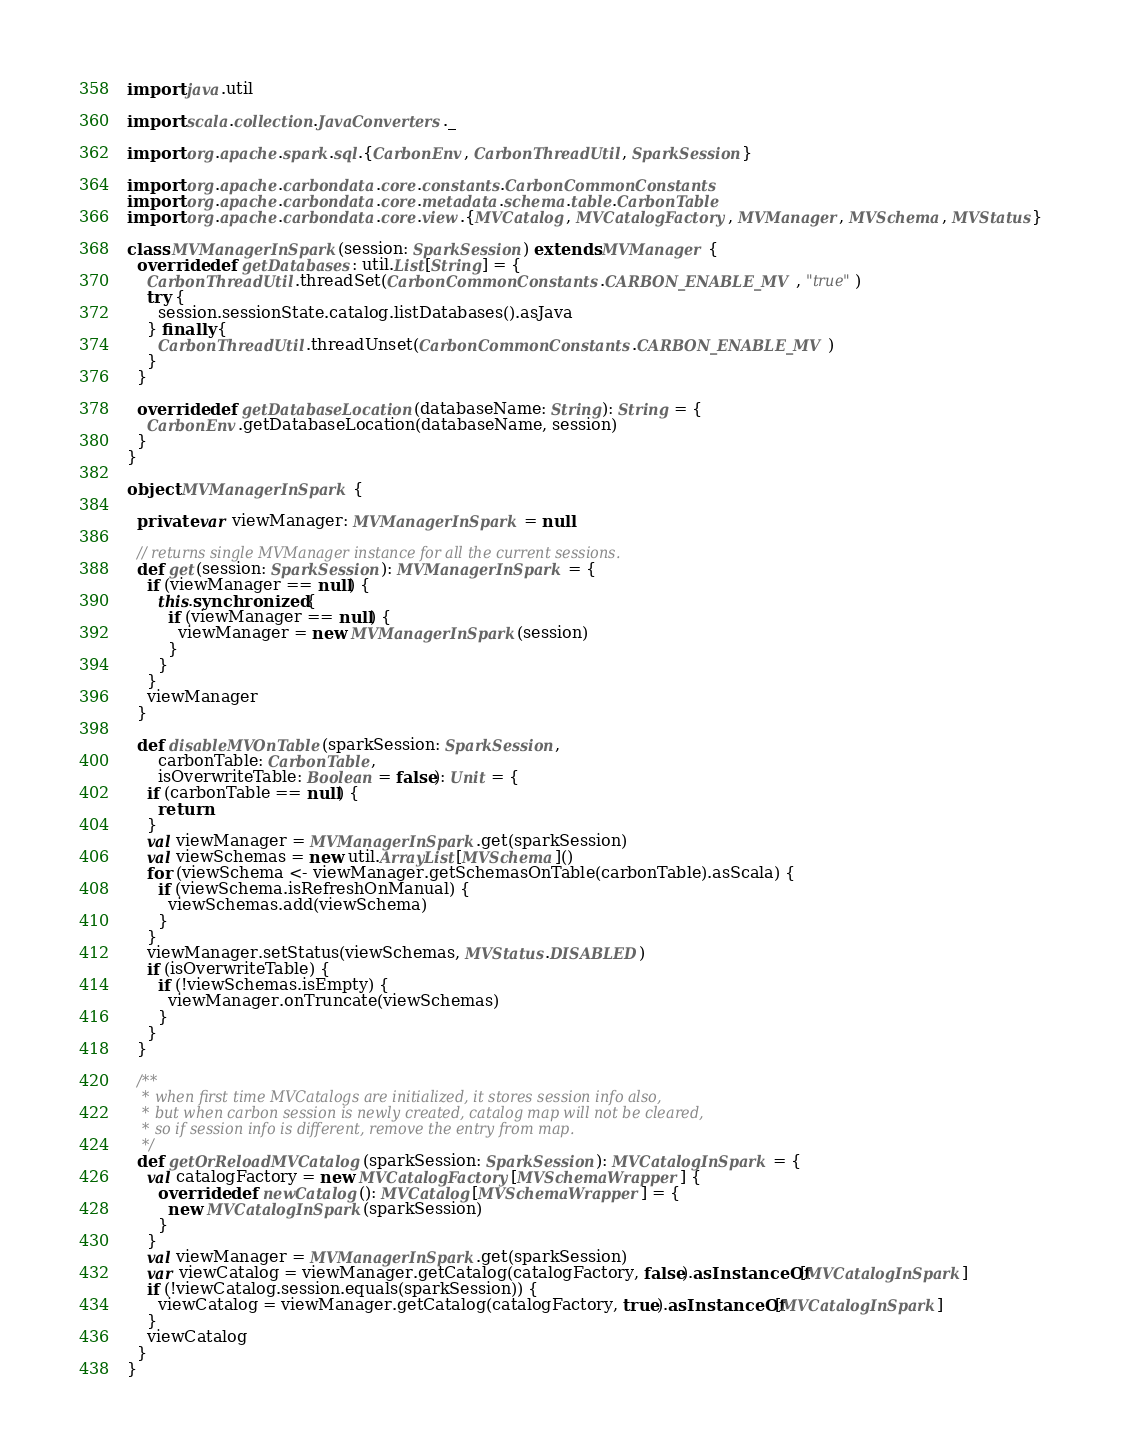<code> <loc_0><loc_0><loc_500><loc_500><_Scala_>
import java.util

import scala.collection.JavaConverters._

import org.apache.spark.sql.{CarbonEnv, CarbonThreadUtil, SparkSession}

import org.apache.carbondata.core.constants.CarbonCommonConstants
import org.apache.carbondata.core.metadata.schema.table.CarbonTable
import org.apache.carbondata.core.view.{MVCatalog, MVCatalogFactory, MVManager, MVSchema, MVStatus}

class MVManagerInSpark(session: SparkSession) extends MVManager {
  override def getDatabases: util.List[String] = {
    CarbonThreadUtil.threadSet(CarbonCommonConstants.CARBON_ENABLE_MV, "true")
    try {
      session.sessionState.catalog.listDatabases().asJava
    } finally {
      CarbonThreadUtil.threadUnset(CarbonCommonConstants.CARBON_ENABLE_MV)
    }
  }

  override def getDatabaseLocation(databaseName: String): String = {
    CarbonEnv.getDatabaseLocation(databaseName, session)
  }
}

object MVManagerInSpark {

  private var viewManager: MVManagerInSpark = null

  // returns single MVManager instance for all the current sessions.
  def get(session: SparkSession): MVManagerInSpark = {
    if (viewManager == null) {
      this.synchronized {
        if (viewManager == null) {
          viewManager = new MVManagerInSpark(session)
        }
      }
    }
    viewManager
  }

  def disableMVOnTable(sparkSession: SparkSession,
      carbonTable: CarbonTable,
      isOverwriteTable: Boolean = false): Unit = {
    if (carbonTable == null) {
      return
    }
    val viewManager = MVManagerInSpark.get(sparkSession)
    val viewSchemas = new util.ArrayList[MVSchema]()
    for (viewSchema <- viewManager.getSchemasOnTable(carbonTable).asScala) {
      if (viewSchema.isRefreshOnManual) {
        viewSchemas.add(viewSchema)
      }
    }
    viewManager.setStatus(viewSchemas, MVStatus.DISABLED)
    if (isOverwriteTable) {
      if (!viewSchemas.isEmpty) {
        viewManager.onTruncate(viewSchemas)
      }
    }
  }

  /**
   * when first time MVCatalogs are initialized, it stores session info also,
   * but when carbon session is newly created, catalog map will not be cleared,
   * so if session info is different, remove the entry from map.
   */
  def getOrReloadMVCatalog(sparkSession: SparkSession): MVCatalogInSpark = {
    val catalogFactory = new MVCatalogFactory[MVSchemaWrapper] {
      override def newCatalog(): MVCatalog[MVSchemaWrapper] = {
        new MVCatalogInSpark(sparkSession)
      }
    }
    val viewManager = MVManagerInSpark.get(sparkSession)
    var viewCatalog = viewManager.getCatalog(catalogFactory, false).asInstanceOf[MVCatalogInSpark]
    if (!viewCatalog.session.equals(sparkSession)) {
      viewCatalog = viewManager.getCatalog(catalogFactory, true).asInstanceOf[MVCatalogInSpark]
    }
    viewCatalog
  }
}
</code> 